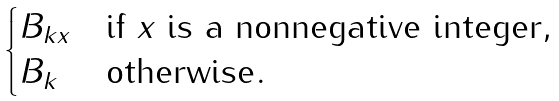Convert formula to latex. <formula><loc_0><loc_0><loc_500><loc_500>\begin{cases} B _ { k x } & \text {if $x$ is a nonnegative integer} , \\ B _ { k } & \text {otherwise} . \end{cases}</formula> 